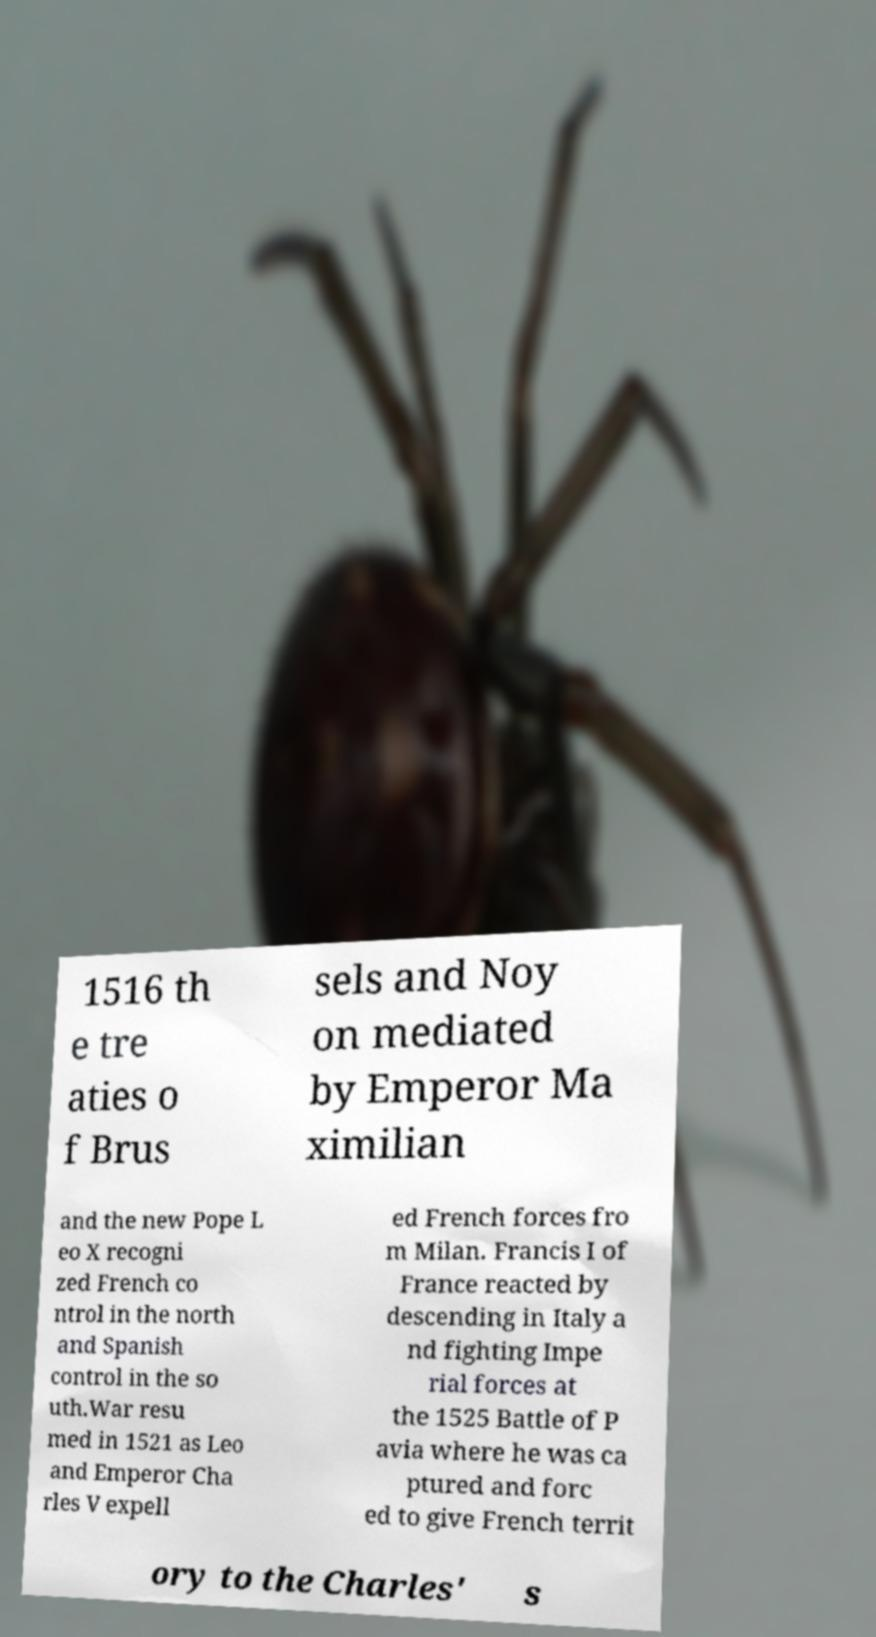I need the written content from this picture converted into text. Can you do that? 1516 th e tre aties o f Brus sels and Noy on mediated by Emperor Ma ximilian and the new Pope L eo X recogni zed French co ntrol in the north and Spanish control in the so uth.War resu med in 1521 as Leo and Emperor Cha rles V expell ed French forces fro m Milan. Francis I of France reacted by descending in Italy a nd fighting Impe rial forces at the 1525 Battle of P avia where he was ca ptured and forc ed to give French territ ory to the Charles' s 